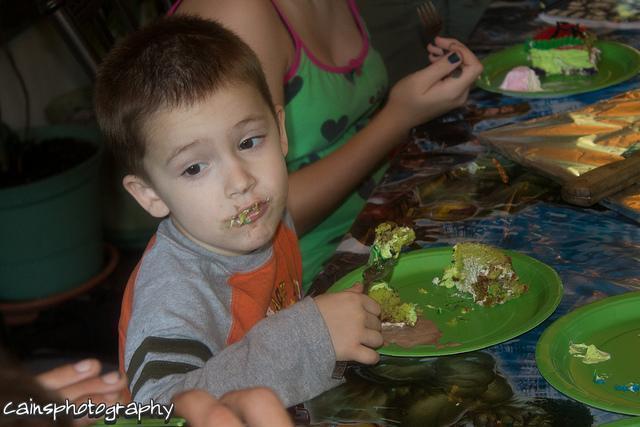How many plates of food are on this table?
Give a very brief answer. 3. How many kids in the photo?
Give a very brief answer. 1. How many cakes are there?
Give a very brief answer. 2. How many dining tables are visible?
Give a very brief answer. 1. How many people are in the photo?
Give a very brief answer. 2. How many potted plants are in the picture?
Give a very brief answer. 1. How many benches are there?
Give a very brief answer. 0. 